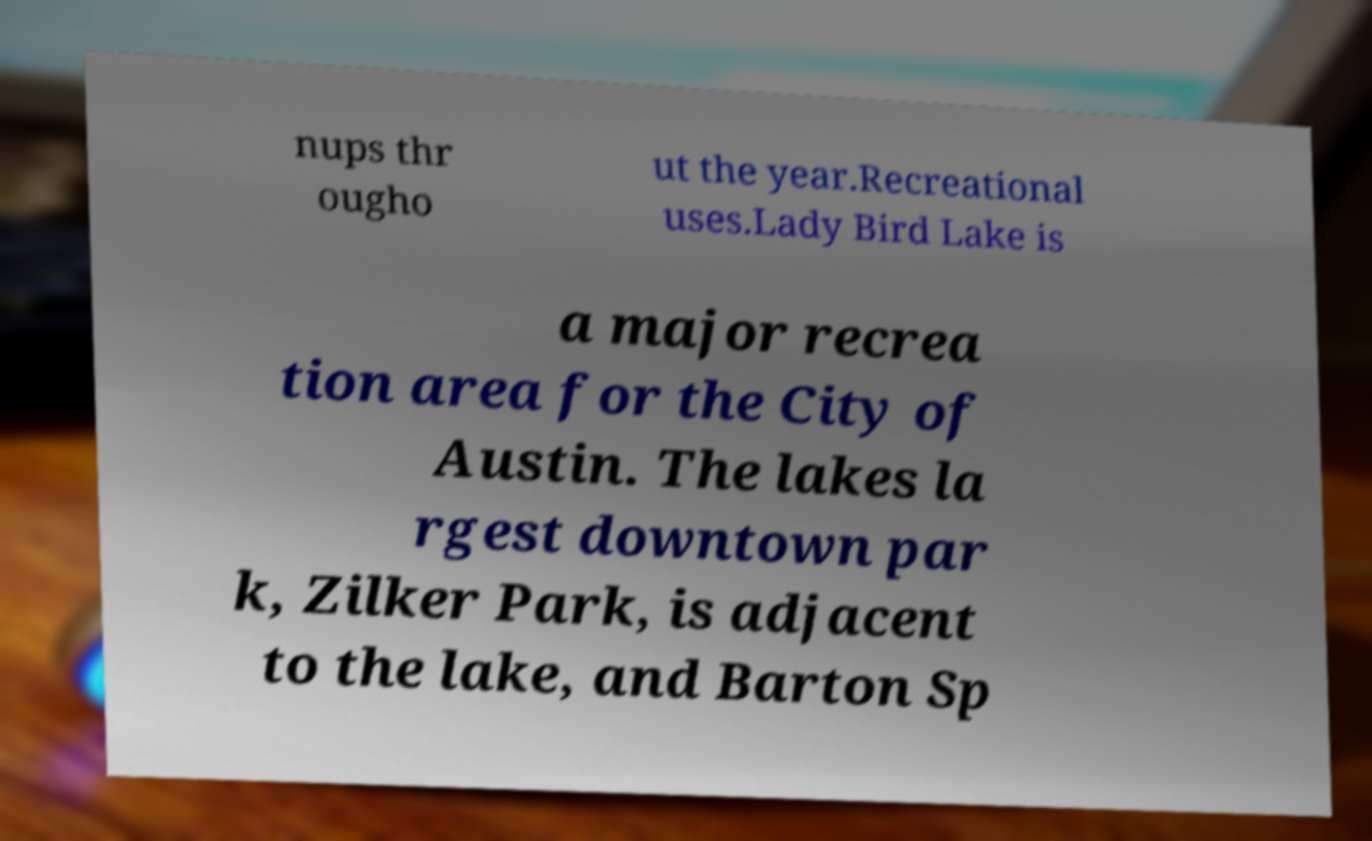Can you accurately transcribe the text from the provided image for me? nups thr ougho ut the year.Recreational uses.Lady Bird Lake is a major recrea tion area for the City of Austin. The lakes la rgest downtown par k, Zilker Park, is adjacent to the lake, and Barton Sp 